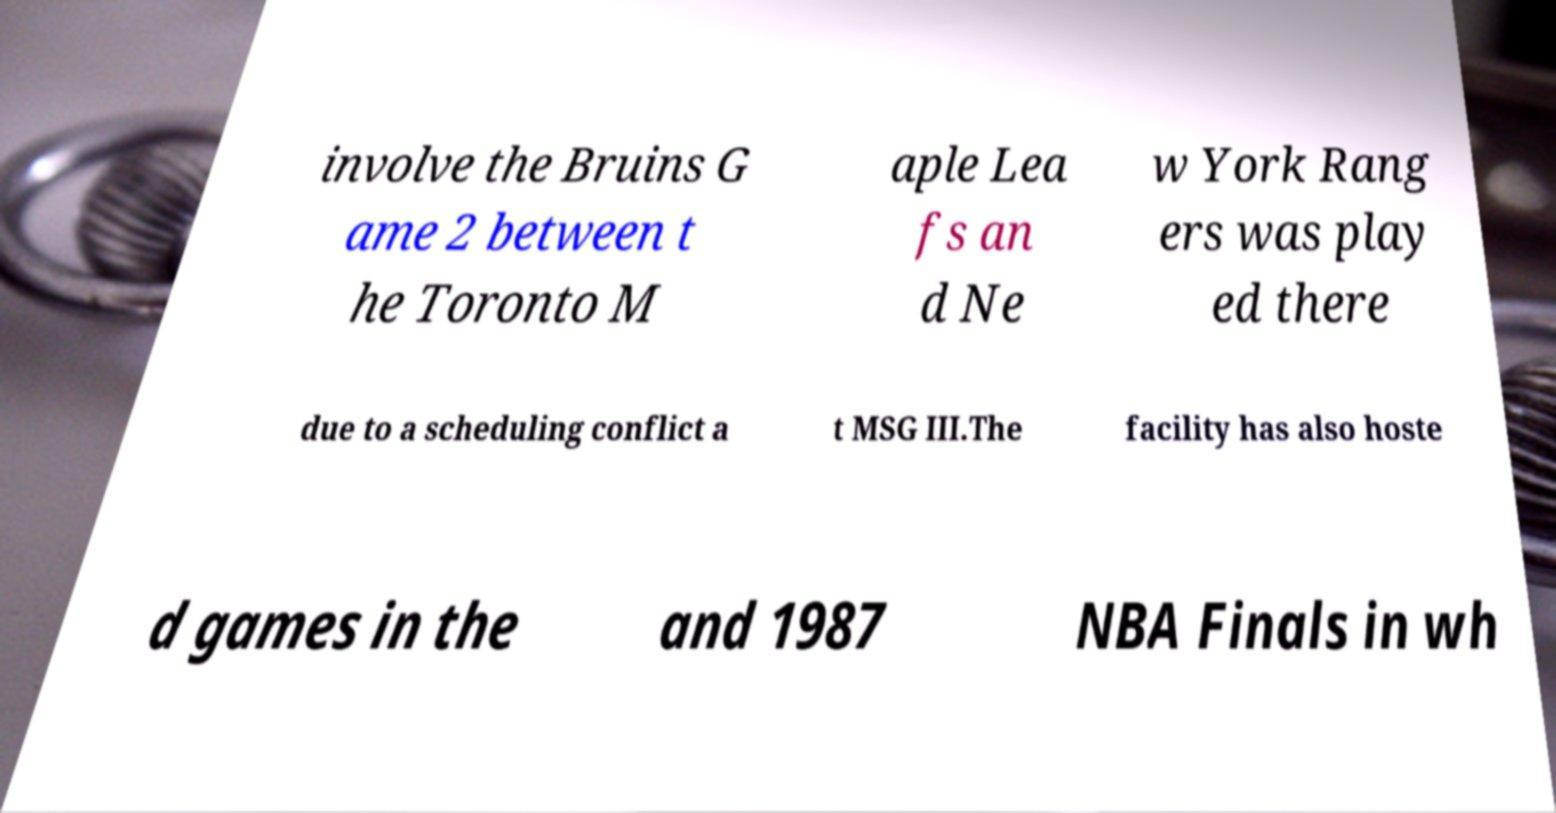I need the written content from this picture converted into text. Can you do that? involve the Bruins G ame 2 between t he Toronto M aple Lea fs an d Ne w York Rang ers was play ed there due to a scheduling conflict a t MSG III.The facility has also hoste d games in the and 1987 NBA Finals in wh 